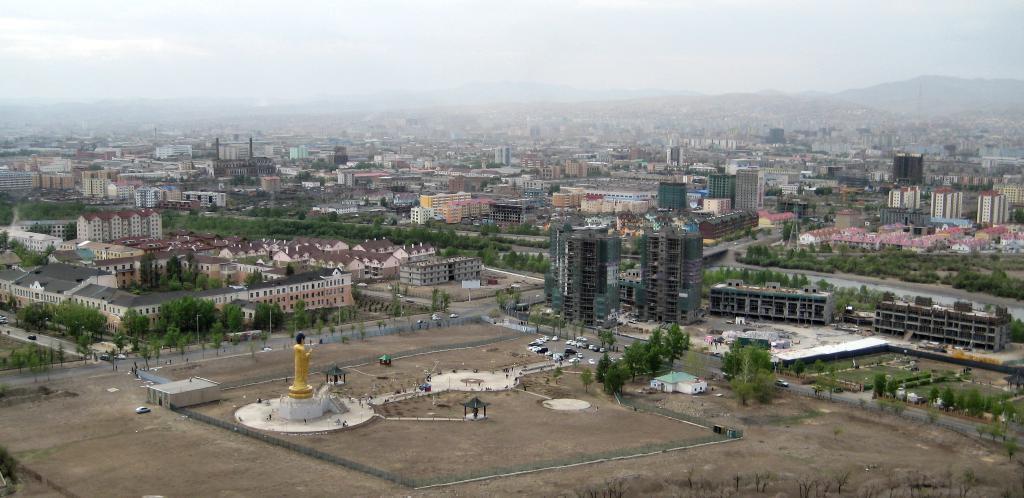In one or two sentences, can you explain what this image depicts? This is a picture of a city, where there are vehicles, roads, buildings, trees, statute, hills , and in the background there is sky. 